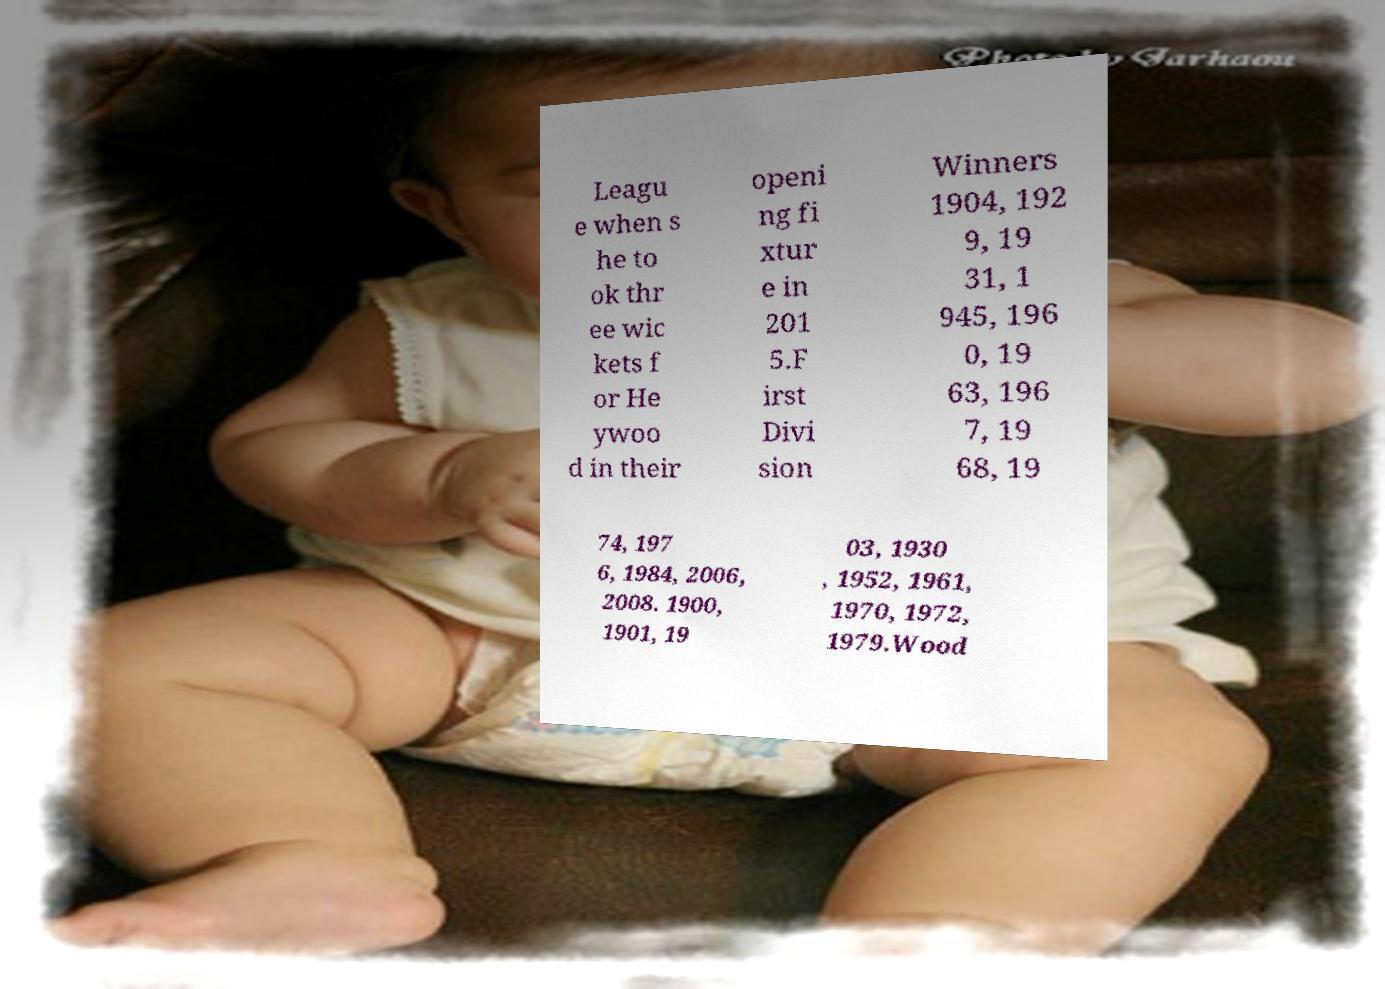For documentation purposes, I need the text within this image transcribed. Could you provide that? Leagu e when s he to ok thr ee wic kets f or He ywoo d in their openi ng fi xtur e in 201 5.F irst Divi sion Winners 1904, 192 9, 19 31, 1 945, 196 0, 19 63, 196 7, 19 68, 19 74, 197 6, 1984, 2006, 2008. 1900, 1901, 19 03, 1930 , 1952, 1961, 1970, 1972, 1979.Wood 